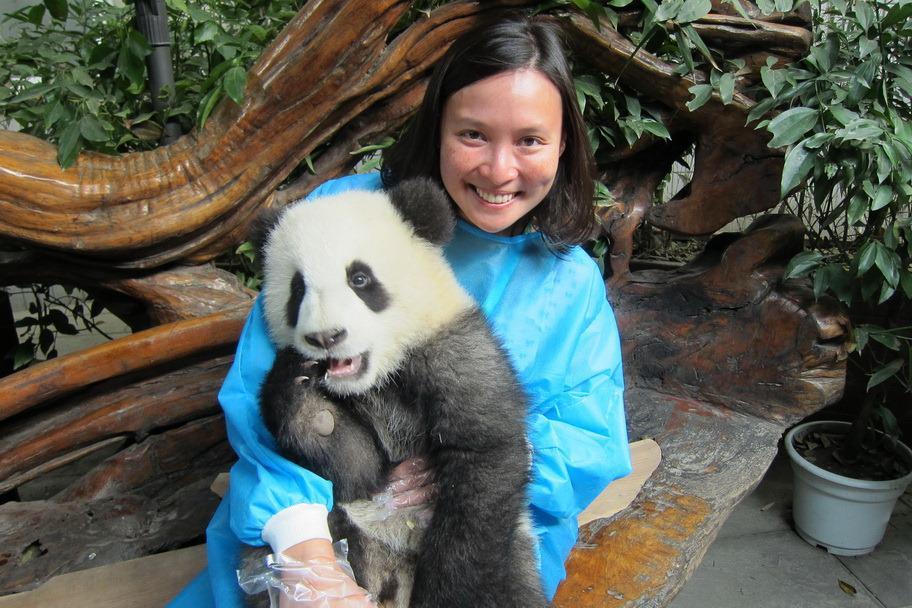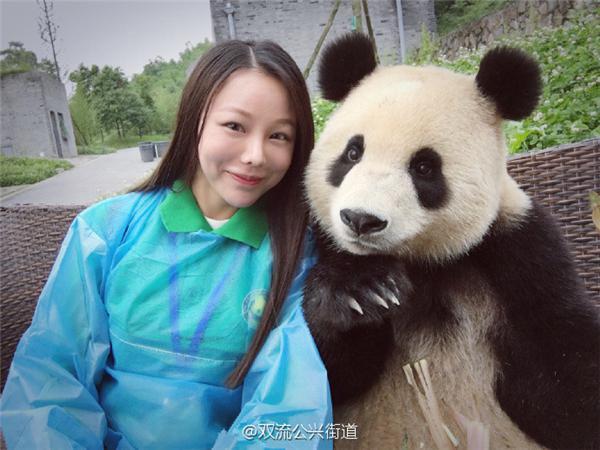The first image is the image on the left, the second image is the image on the right. Assess this claim about the two images: "There is at least one human face behind a panda bear.". Correct or not? Answer yes or no. Yes. The first image is the image on the left, the second image is the image on the right. For the images shown, is this caption "There are no people, only pandas, and one of the pandas is with plants." true? Answer yes or no. No. 